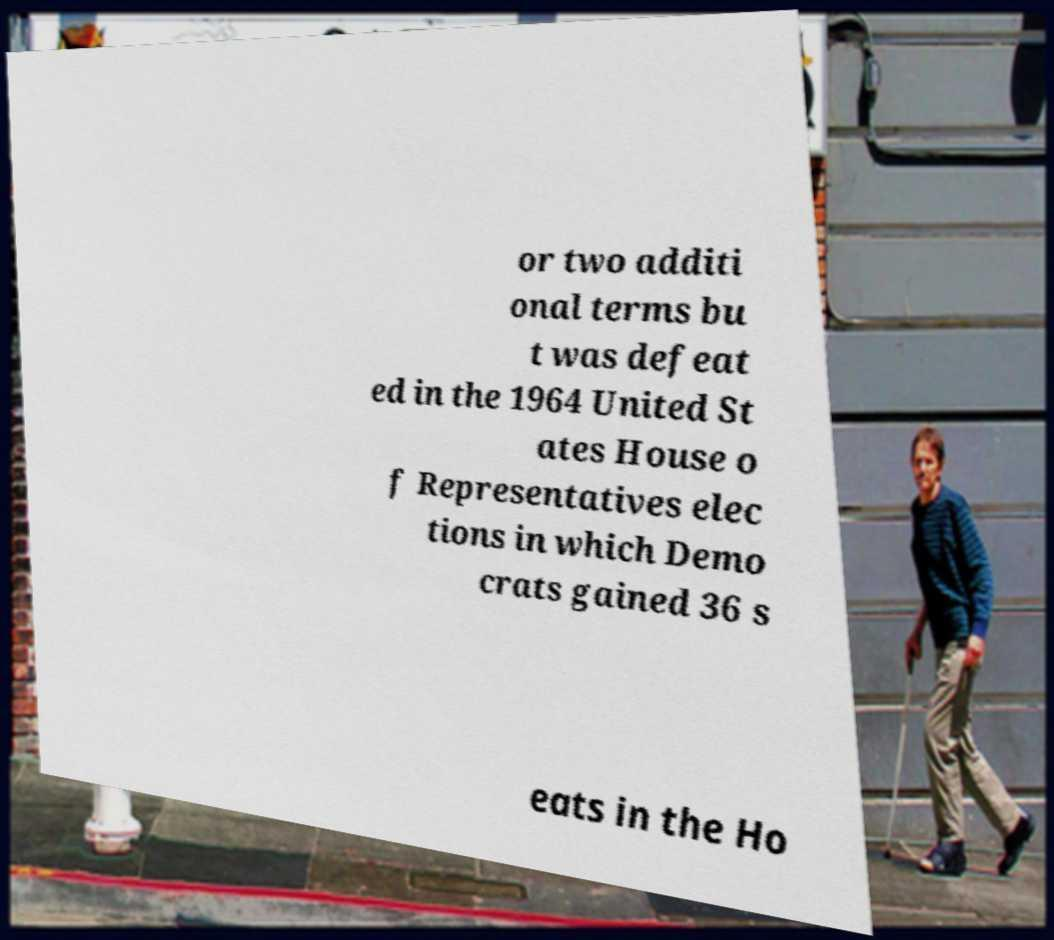There's text embedded in this image that I need extracted. Can you transcribe it verbatim? or two additi onal terms bu t was defeat ed in the 1964 United St ates House o f Representatives elec tions in which Demo crats gained 36 s eats in the Ho 